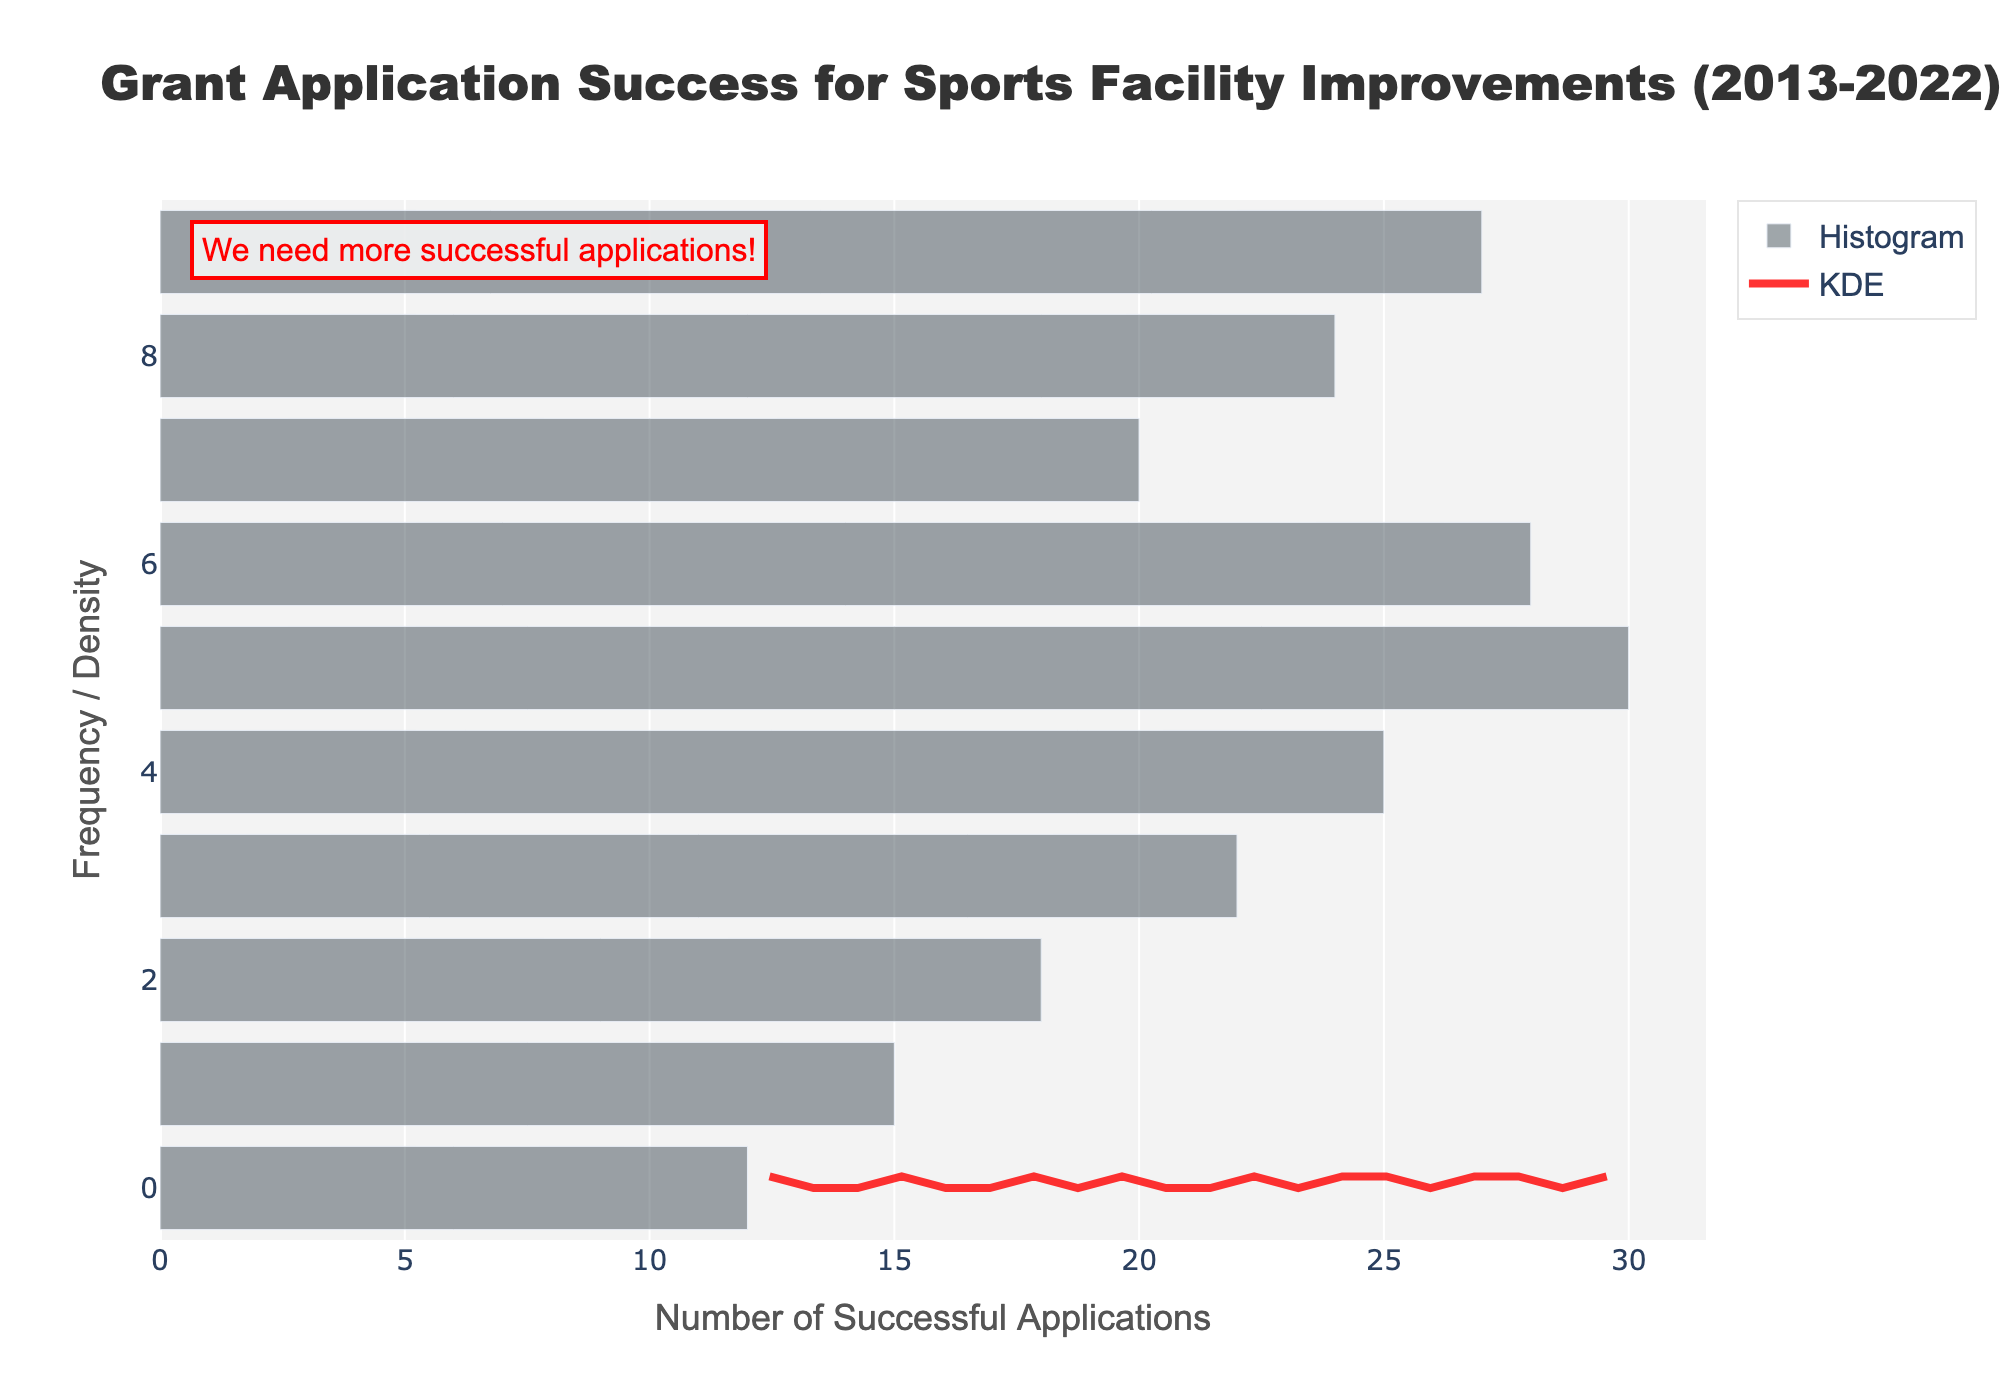What is the title of the plot? The title is displayed prominently at the top of the plot. It reads, "Grant Application Success for Sports Facility Improvements (2013-2022)."
Answer: Grant Application Success for Sports Facility Improvements (2013-2022) What does the y-axis represent? The y-axis is labeled "Frequency / Density," indicating it shows either the frequency of successful applications or the density of the KDE curve.
Answer: Frequency / Density What is the color of the histogram bars? The histogram bars are colored light gray, as can be seen from their appearance.
Answer: Light gray What is the trend of the KDE curve? The KDE curve shows a peak around the mid-range of successful applications, indicating a higher density of applications in that range and then slowly declines towards both ends.
Answer: Peaks at mid-range and declines How many histogram bars are there? There are 10 distinct bars in the histogram, each representing a year from 2013 to 2022.
Answer: 10 Which year had the highest number of successful applications? The tallest bar in the histogram represents the year with the highest number of successful applications, which is 2018.
Answer: 2018 What is the range for the KDE plot's x-values? The range for the x-values where the KDE is computed can be inferred from the start and end points of the KDE curve along the x-axis, typically covering the range of data values.
Answer: From 12 to 30 Describe the annotation in the plot. The annotation in the plot reads, "We need more successful applications!" in red text located at the upper left corner, indicating a call for increasing successful grant applications.
Answer: We need more successful applications! What is the average number of successful applications over the years? To find the average, sum the successful applications for each year and divide by the number of years: (12+15+18+22+25+30+28+20+24+27)/10 = 22.1
Answer: 22.1 Which years had more than 25 successful applications? Years with histogram bars corresponding to values more than 25 are identified as 2018, 2019, and 2022.
Answer: 2018, 2019, 2022 What is the shape of the KDE curve compared to the histogram? The KDE curve smoothens out the peaks and troughs of the histogram, offering a continuous representation. The curve generally follows the distribution pattern of the histogram.
Answer: Smooth, continuous curve following histogram distribution 